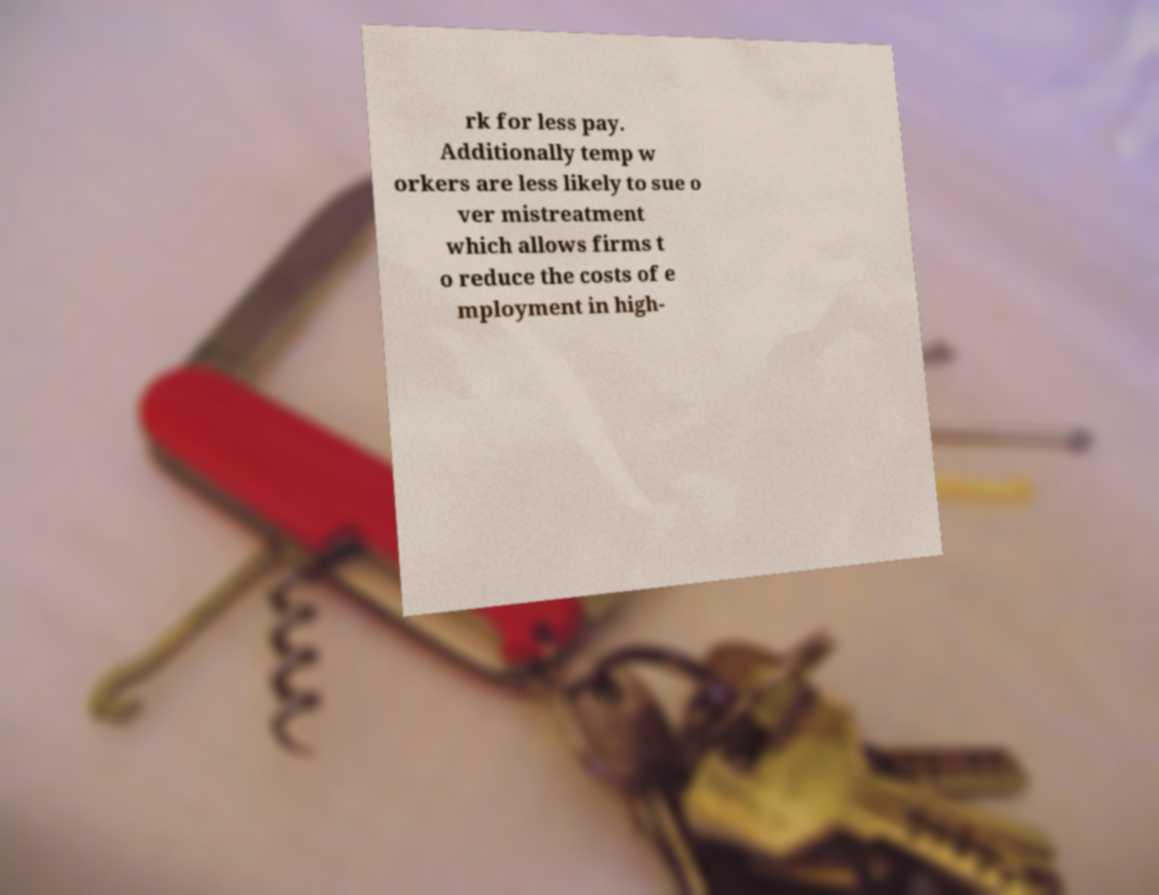Could you extract and type out the text from this image? rk for less pay. Additionally temp w orkers are less likely to sue o ver mistreatment which allows firms t o reduce the costs of e mployment in high- 